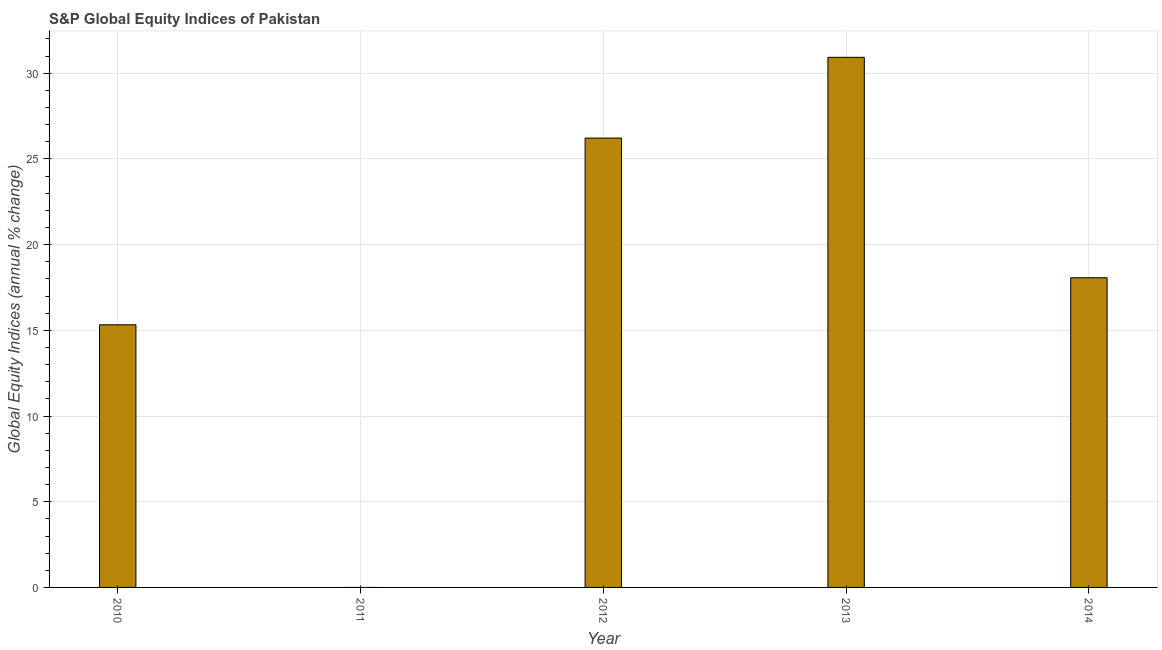What is the title of the graph?
Provide a succinct answer. S&P Global Equity Indices of Pakistan. What is the label or title of the X-axis?
Make the answer very short. Year. What is the label or title of the Y-axis?
Your answer should be very brief. Global Equity Indices (annual % change). What is the s&p global equity indices in 2012?
Keep it short and to the point. 26.21. Across all years, what is the maximum s&p global equity indices?
Keep it short and to the point. 30.92. Across all years, what is the minimum s&p global equity indices?
Provide a succinct answer. 0. In which year was the s&p global equity indices maximum?
Your answer should be very brief. 2013. What is the sum of the s&p global equity indices?
Ensure brevity in your answer.  90.52. What is the difference between the s&p global equity indices in 2010 and 2014?
Offer a terse response. -2.75. What is the average s&p global equity indices per year?
Ensure brevity in your answer.  18.11. What is the median s&p global equity indices?
Your answer should be very brief. 18.07. In how many years, is the s&p global equity indices greater than 27 %?
Keep it short and to the point. 1. What is the ratio of the s&p global equity indices in 2010 to that in 2014?
Your answer should be compact. 0.85. Is the difference between the s&p global equity indices in 2010 and 2013 greater than the difference between any two years?
Your answer should be very brief. No. What is the difference between the highest and the second highest s&p global equity indices?
Provide a short and direct response. 4.71. What is the difference between the highest and the lowest s&p global equity indices?
Keep it short and to the point. 30.92. In how many years, is the s&p global equity indices greater than the average s&p global equity indices taken over all years?
Provide a succinct answer. 2. How many bars are there?
Provide a short and direct response. 4. How many years are there in the graph?
Your answer should be compact. 5. What is the Global Equity Indices (annual % change) of 2010?
Ensure brevity in your answer.  15.32. What is the Global Equity Indices (annual % change) in 2012?
Your response must be concise. 26.21. What is the Global Equity Indices (annual % change) of 2013?
Offer a very short reply. 30.92. What is the Global Equity Indices (annual % change) of 2014?
Provide a short and direct response. 18.07. What is the difference between the Global Equity Indices (annual % change) in 2010 and 2012?
Keep it short and to the point. -10.89. What is the difference between the Global Equity Indices (annual % change) in 2010 and 2013?
Offer a very short reply. -15.6. What is the difference between the Global Equity Indices (annual % change) in 2010 and 2014?
Offer a terse response. -2.75. What is the difference between the Global Equity Indices (annual % change) in 2012 and 2013?
Make the answer very short. -4.71. What is the difference between the Global Equity Indices (annual % change) in 2012 and 2014?
Offer a very short reply. 8.15. What is the difference between the Global Equity Indices (annual % change) in 2013 and 2014?
Offer a very short reply. 12.86. What is the ratio of the Global Equity Indices (annual % change) in 2010 to that in 2012?
Give a very brief answer. 0.58. What is the ratio of the Global Equity Indices (annual % change) in 2010 to that in 2013?
Your response must be concise. 0.49. What is the ratio of the Global Equity Indices (annual % change) in 2010 to that in 2014?
Keep it short and to the point. 0.85. What is the ratio of the Global Equity Indices (annual % change) in 2012 to that in 2013?
Provide a short and direct response. 0.85. What is the ratio of the Global Equity Indices (annual % change) in 2012 to that in 2014?
Offer a terse response. 1.45. What is the ratio of the Global Equity Indices (annual % change) in 2013 to that in 2014?
Give a very brief answer. 1.71. 